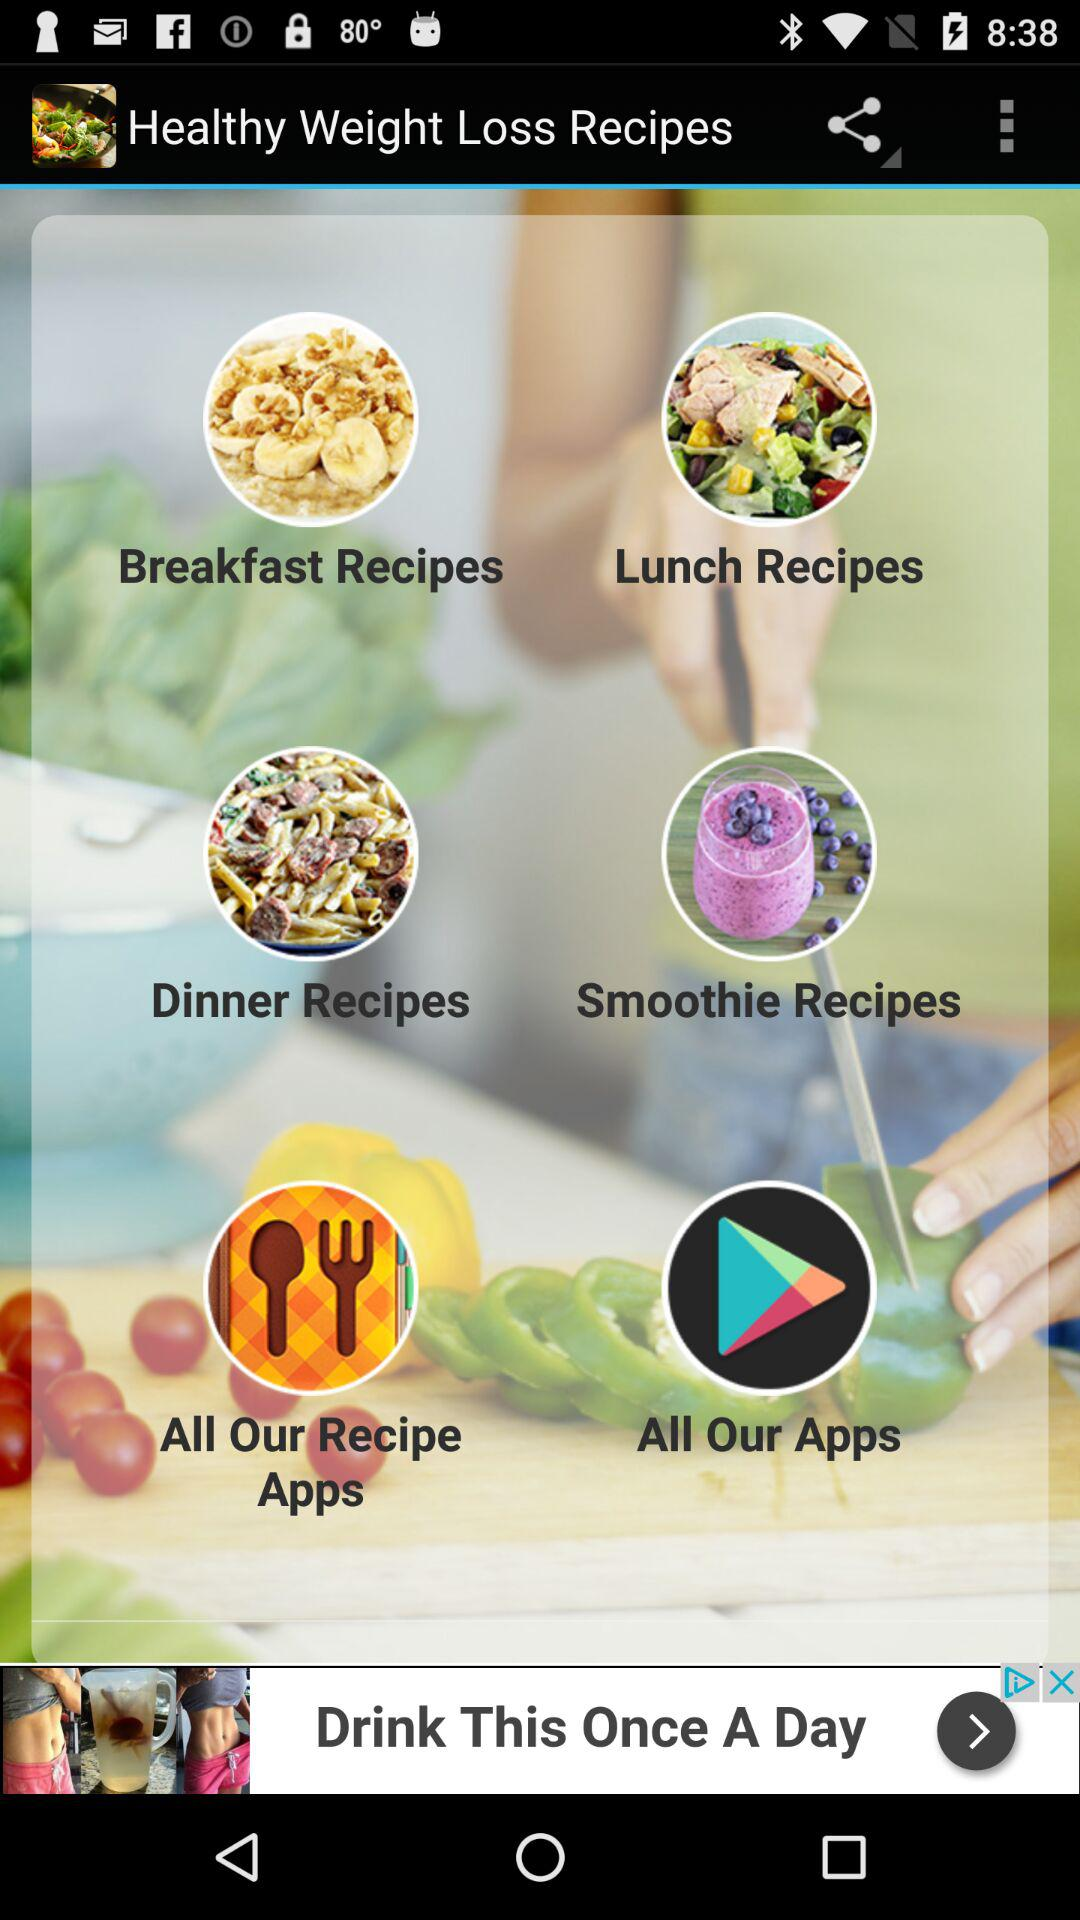How many recipe categories are there?
Answer the question using a single word or phrase. 4 